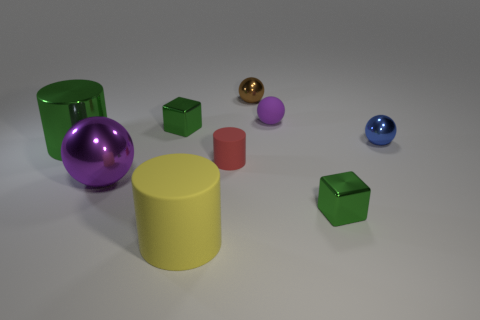Add 1 green cylinders. How many objects exist? 10 Subtract all balls. How many objects are left? 5 Add 4 tiny matte cylinders. How many tiny matte cylinders exist? 5 Subtract 0 blue cubes. How many objects are left? 9 Subtract all big blue rubber things. Subtract all small purple balls. How many objects are left? 8 Add 1 blue objects. How many blue objects are left? 2 